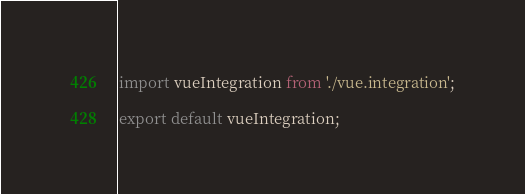Convert code to text. <code><loc_0><loc_0><loc_500><loc_500><_TypeScript_>import vueIntegration from './vue.integration';

export default vueIntegration;
</code> 